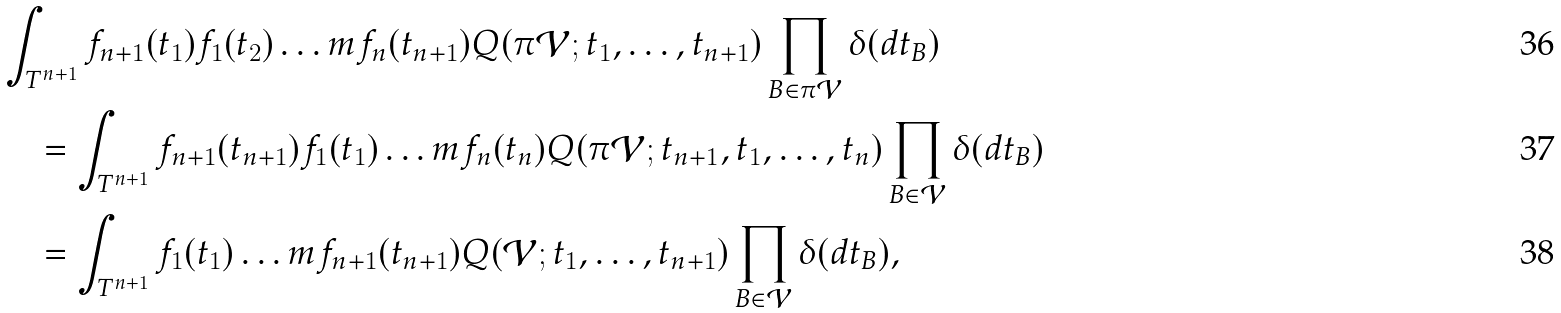Convert formula to latex. <formula><loc_0><loc_0><loc_500><loc_500>& \int _ { T ^ { n + 1 } } f _ { n + 1 } ( t _ { 1 } ) f _ { 1 } ( t _ { 2 } ) \dots m f _ { n } ( t _ { n + 1 } ) Q ( \pi \mathcal { V } ; t _ { 1 } , \dots , t _ { n + 1 } ) \prod _ { B \in \pi \mathcal { V } } \delta ( d t _ { B } ) \\ & \quad = \int _ { T ^ { n + 1 } } f _ { n + 1 } ( t _ { n + 1 } ) f _ { 1 } ( t _ { 1 } ) \dots m f _ { n } ( t _ { n } ) Q ( \pi \mathcal { V } ; t _ { n + 1 } , t _ { 1 } , \dots , t _ { n } ) \prod _ { B \in \mathcal { V } } \delta ( d t _ { B } ) \\ & \quad = \int _ { T ^ { n + 1 } } f _ { 1 } ( t _ { 1 } ) \dots m f _ { n + 1 } ( t _ { n + 1 } ) Q ( \mathcal { V } ; t _ { 1 } , \dots , t _ { n + 1 } ) \prod _ { B \in \mathcal { V } } \delta ( d t _ { B } ) ,</formula> 